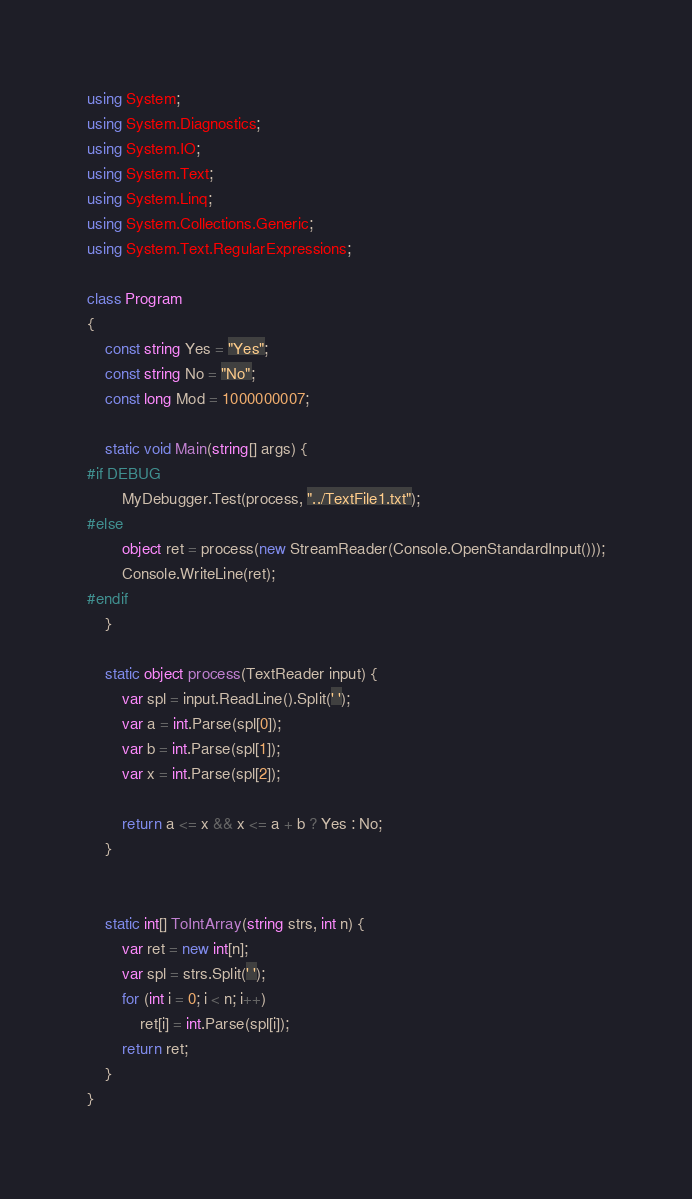Convert code to text. <code><loc_0><loc_0><loc_500><loc_500><_C#_>using System;
using System.Diagnostics;
using System.IO;
using System.Text;
using System.Linq;
using System.Collections.Generic;
using System.Text.RegularExpressions;

class Program
{
    const string Yes = "Yes";
    const string No = "No";
    const long Mod = 1000000007;

    static void Main(string[] args) {
#if DEBUG
        MyDebugger.Test(process, "../TextFile1.txt");
#else
        object ret = process(new StreamReader(Console.OpenStandardInput()));
        Console.WriteLine(ret);
#endif
    }

    static object process(TextReader input) {
        var spl = input.ReadLine().Split(' ');
        var a = int.Parse(spl[0]);
        var b = int.Parse(spl[1]);
        var x = int.Parse(spl[2]);

        return a <= x && x <= a + b ? Yes : No;
    }


    static int[] ToIntArray(string strs, int n) {
        var ret = new int[n];
        var spl = strs.Split(' ');
        for (int i = 0; i < n; i++)
            ret[i] = int.Parse(spl[i]);
        return ret;
    }
}
</code> 